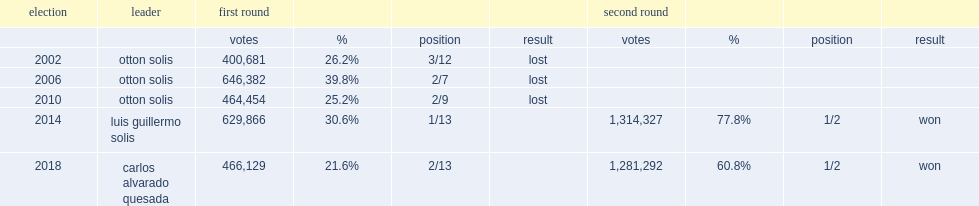How many percent did otton solis finish with of the votes? 25.2. 